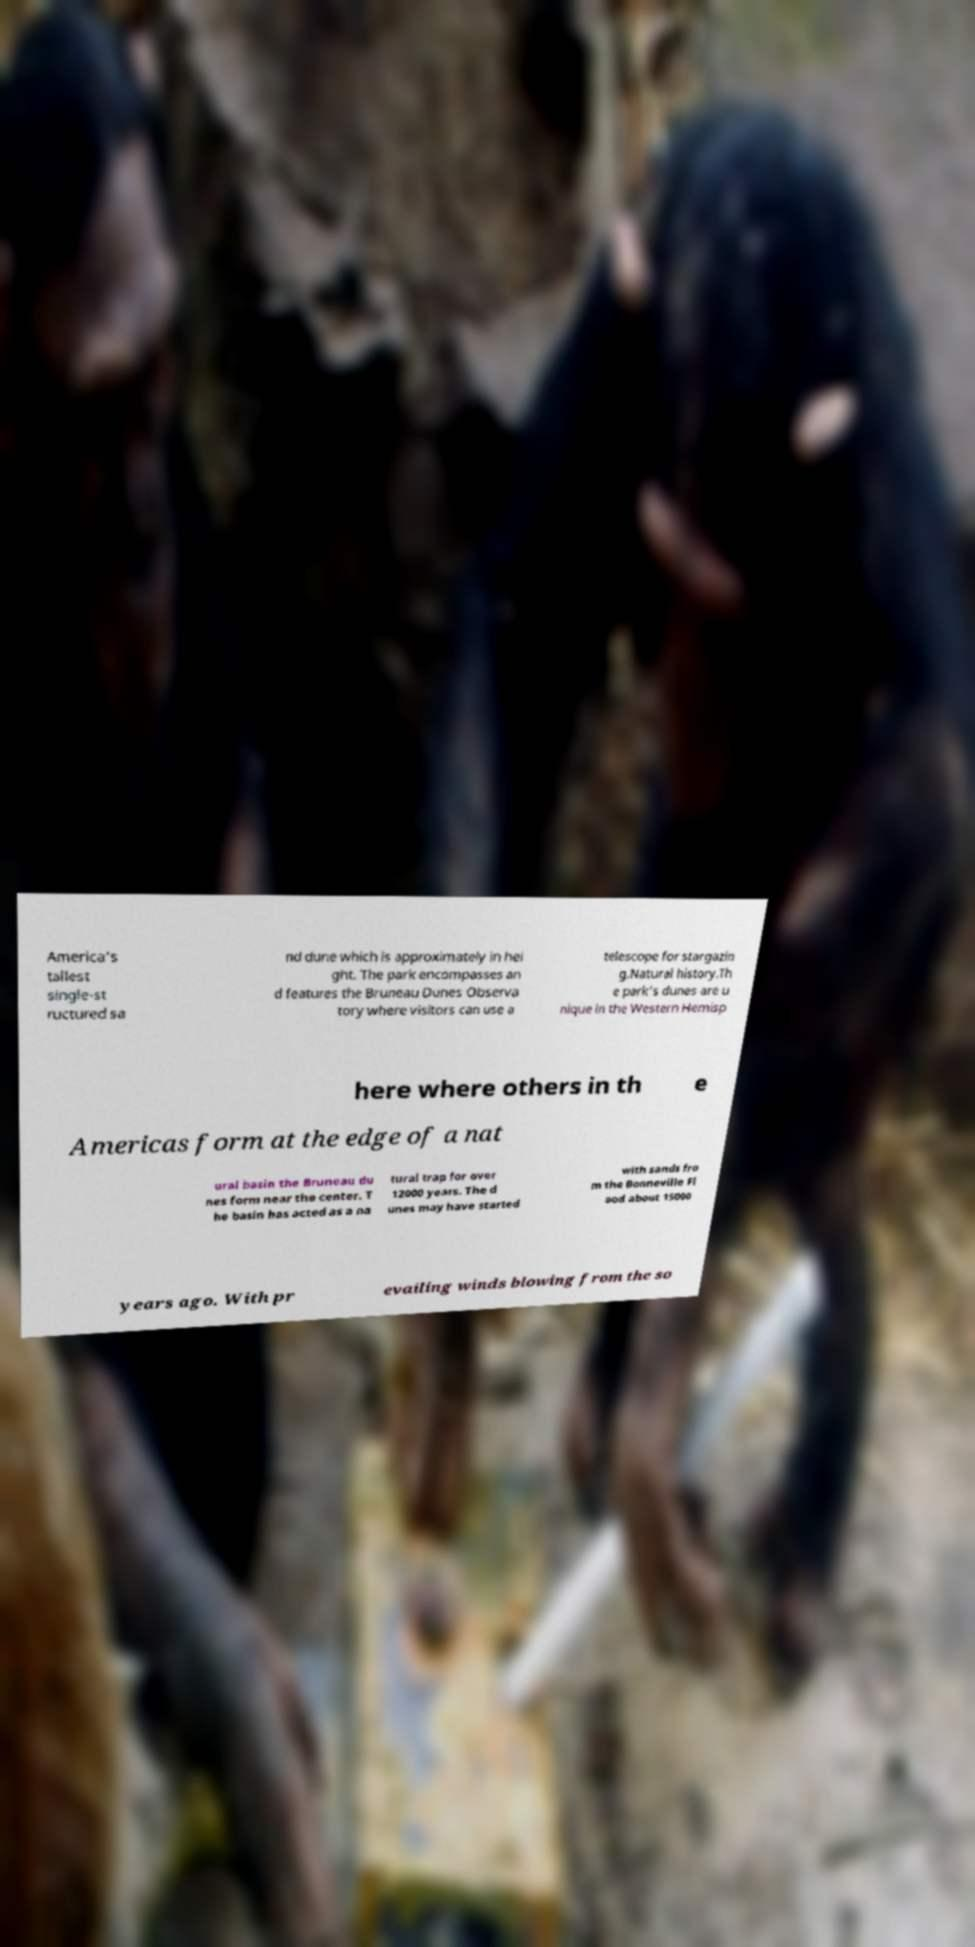Please read and relay the text visible in this image. What does it say? America's tallest single-st ructured sa nd dune which is approximately in hei ght. The park encompasses an d features the Bruneau Dunes Observa tory where visitors can use a telescope for stargazin g.Natural history.Th e park's dunes are u nique in the Western Hemisp here where others in th e Americas form at the edge of a nat ural basin the Bruneau du nes form near the center. T he basin has acted as a na tural trap for over 12000 years. The d unes may have started with sands fro m the Bonneville Fl ood about 15000 years ago. With pr evailing winds blowing from the so 